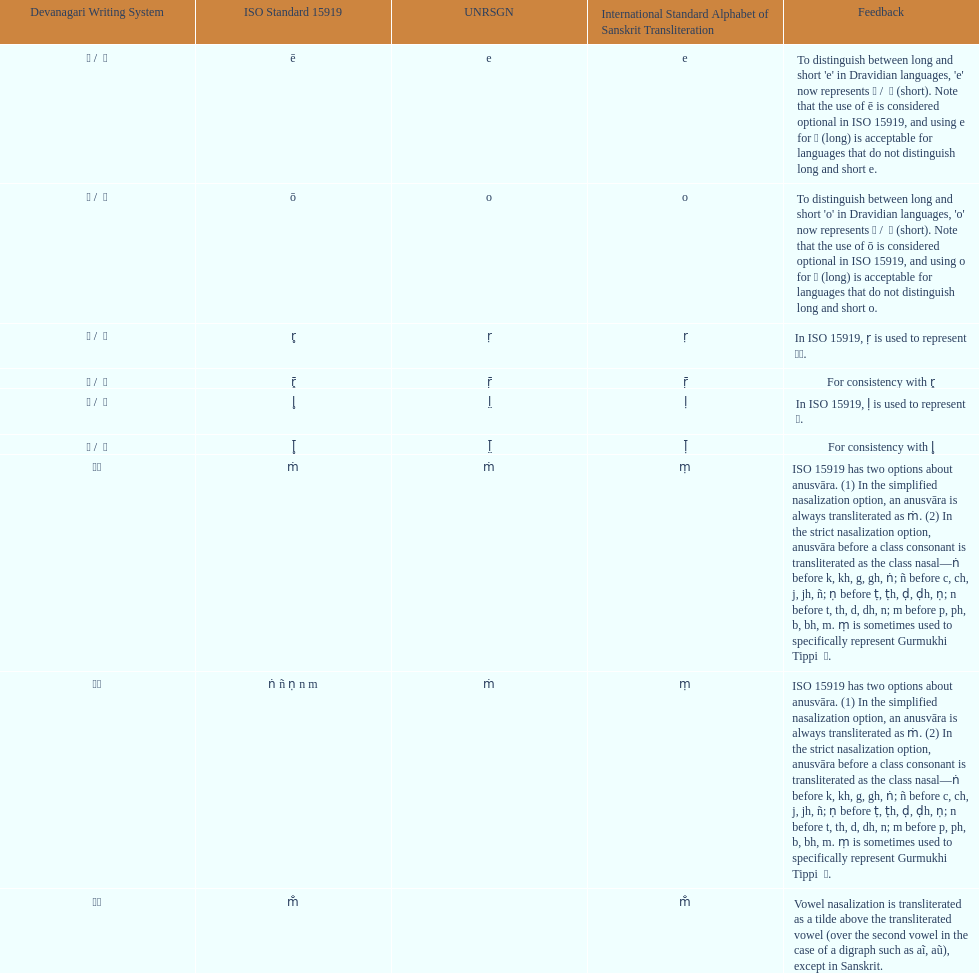Which devanagari transliteration is listed on the top of the table? ए / े. 